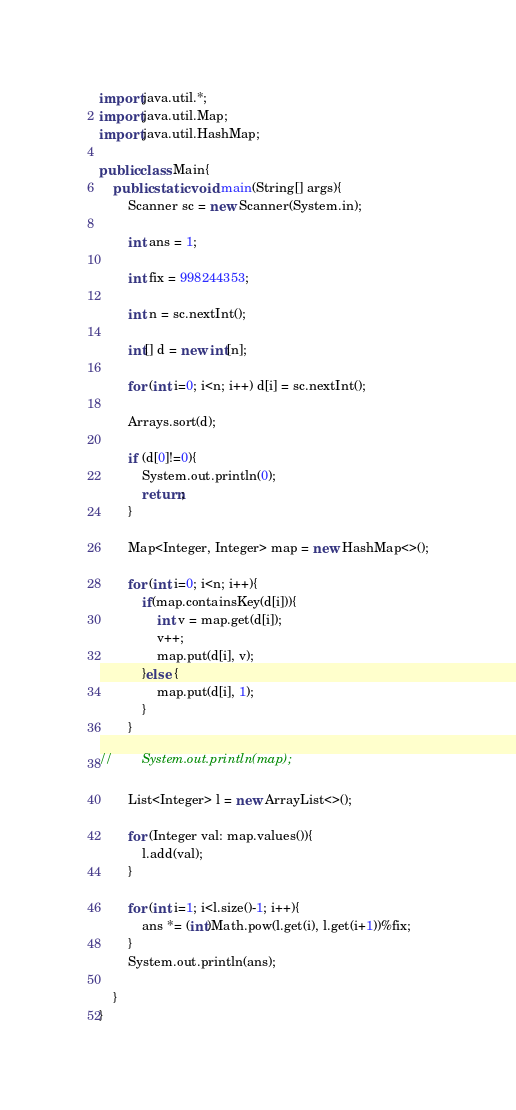Convert code to text. <code><loc_0><loc_0><loc_500><loc_500><_Java_>import java.util.*;
import java.util.Map;
import java.util.HashMap;

public class Main{
    public static void main(String[] args){
        Scanner sc = new Scanner(System.in);

        int ans = 1;

        int fix = 998244353;

        int n = sc.nextInt();

        int[] d = new int[n];

        for (int i=0; i<n; i++) d[i] = sc.nextInt();

        Arrays.sort(d);

        if (d[0]!=0){
            System.out.println(0);
            return;
        }

        Map<Integer, Integer> map = new HashMap<>();

        for (int i=0; i<n; i++){
            if(map.containsKey(d[i])){
                int v = map.get(d[i]);
                v++;
                map.put(d[i], v);
            }else {
                map.put(d[i], 1);
            }
        }

//        System.out.println(map);

        List<Integer> l = new ArrayList<>();

        for (Integer val: map.values()){
            l.add(val);
        }

        for (int i=1; i<l.size()-1; i++){
            ans *= (int)Math.pow(l.get(i), l.get(i+1))%fix;
        }
        System.out.println(ans);

    }
}</code> 